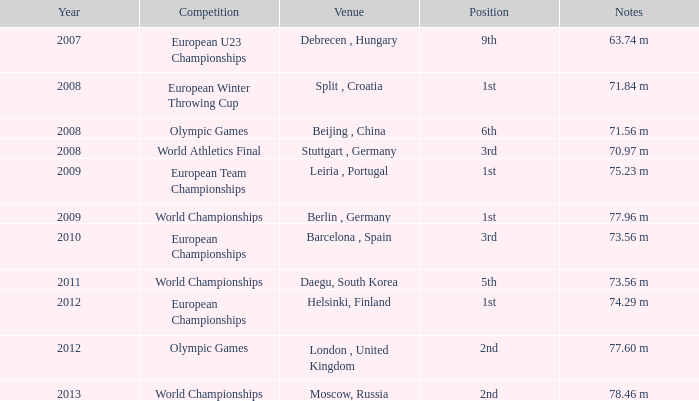Which Year has a Position of 9th? 2007.0. 